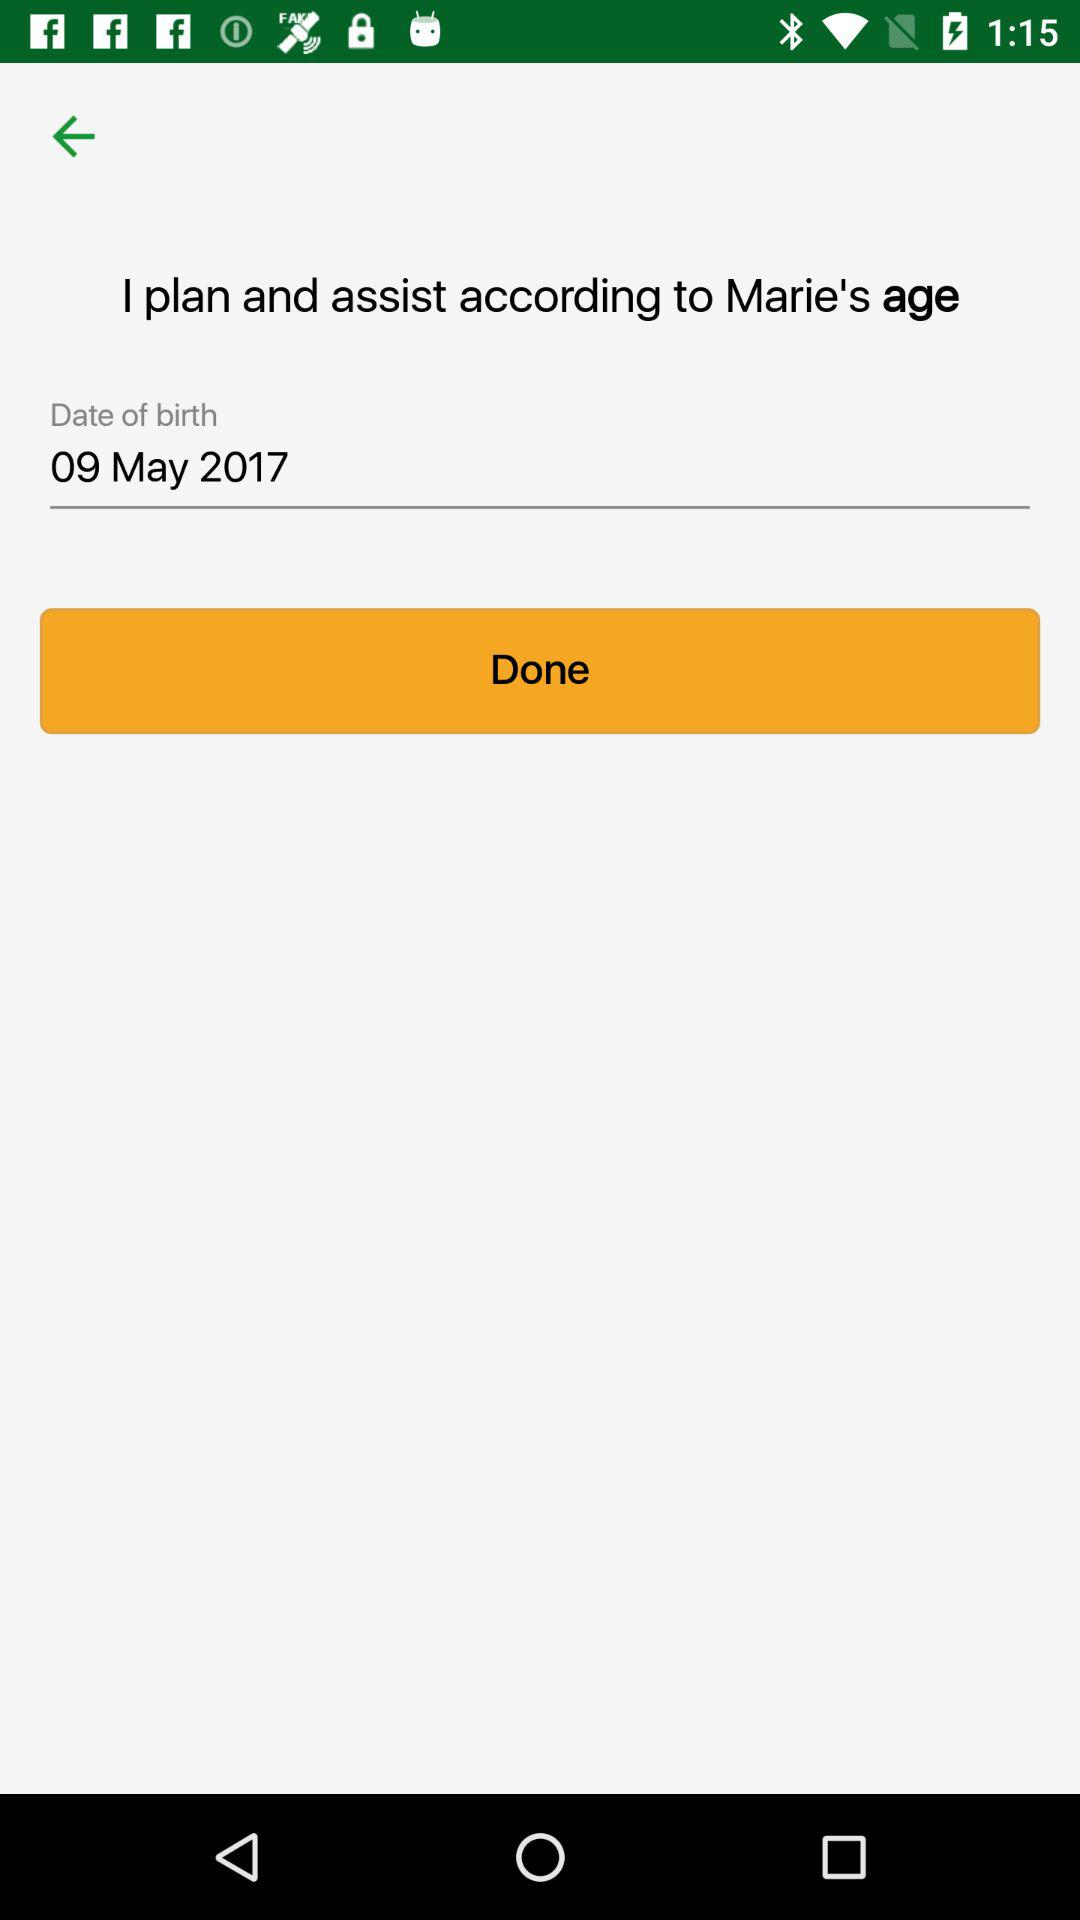What is the date of birthday? The date is May 09, 2017. 